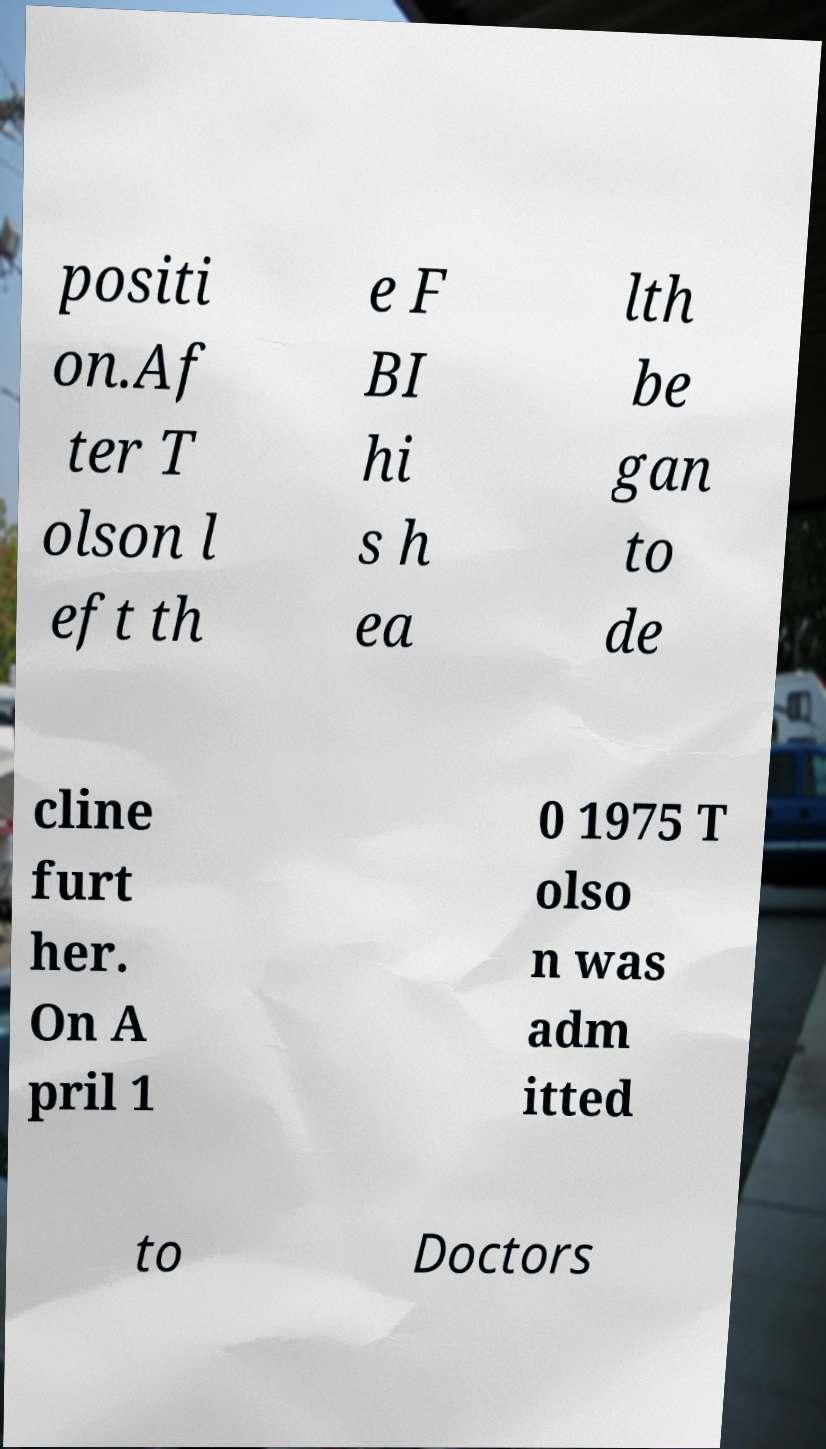Could you assist in decoding the text presented in this image and type it out clearly? positi on.Af ter T olson l eft th e F BI hi s h ea lth be gan to de cline furt her. On A pril 1 0 1975 T olso n was adm itted to Doctors 